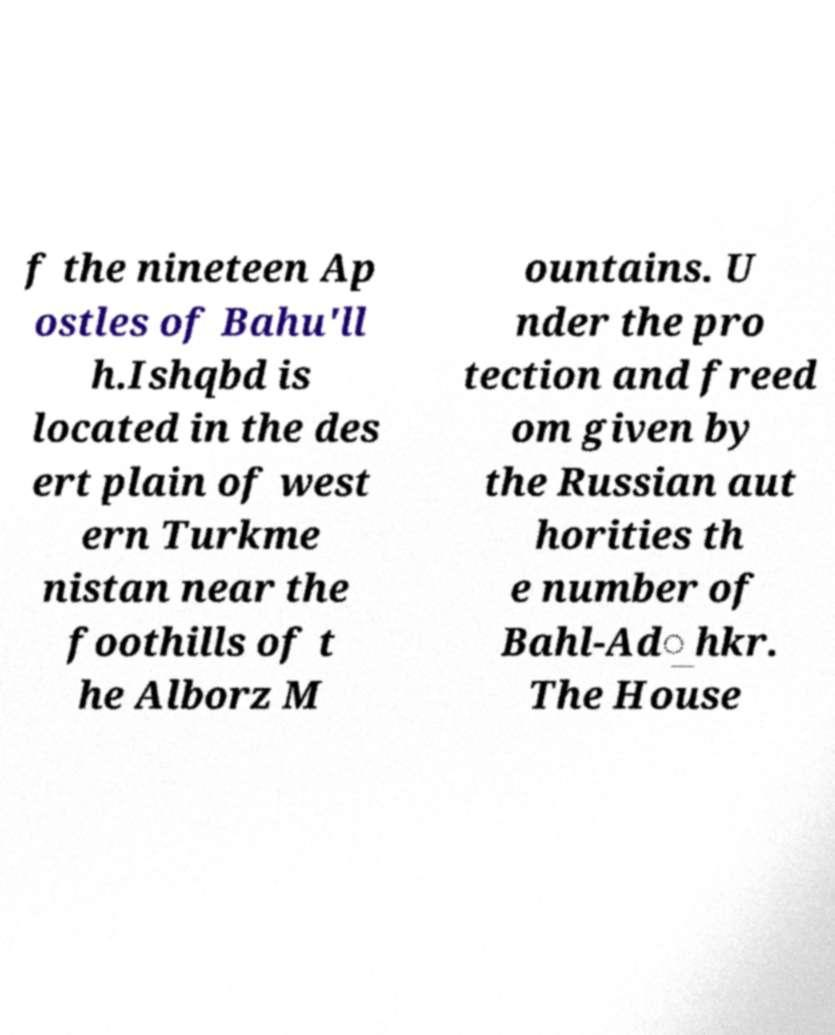Could you extract and type out the text from this image? f the nineteen Ap ostles of Bahu'll h.Ishqbd is located in the des ert plain of west ern Turkme nistan near the foothills of t he Alborz M ountains. U nder the pro tection and freed om given by the Russian aut horities th e number of Bahl-Ad͟hkr. The House 